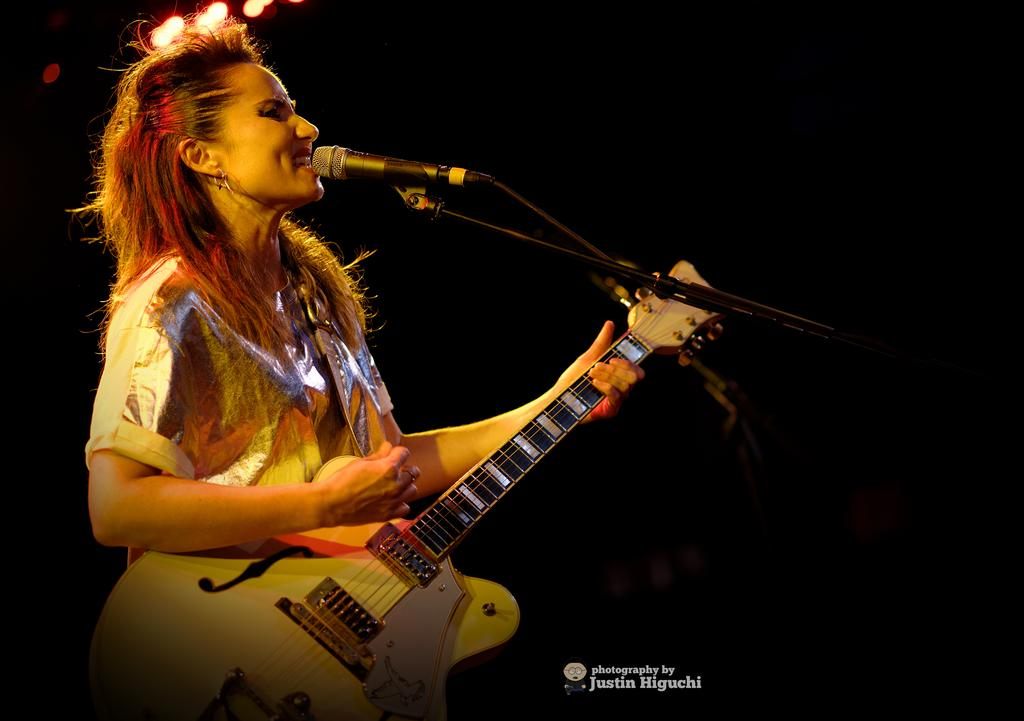Who is the main subject in the image? There is a woman in the image. What is the woman doing in the image? The woman is singing and playing a guitar. What object is the woman holding in the image? The woman is holding a microphone in the image. What type of scarecrow can be seen in the image? There is no scarecrow present in the image. How many years has the woman been playing the guitar in the image? The image does not provide information about how long the woman has been playing the guitar. 